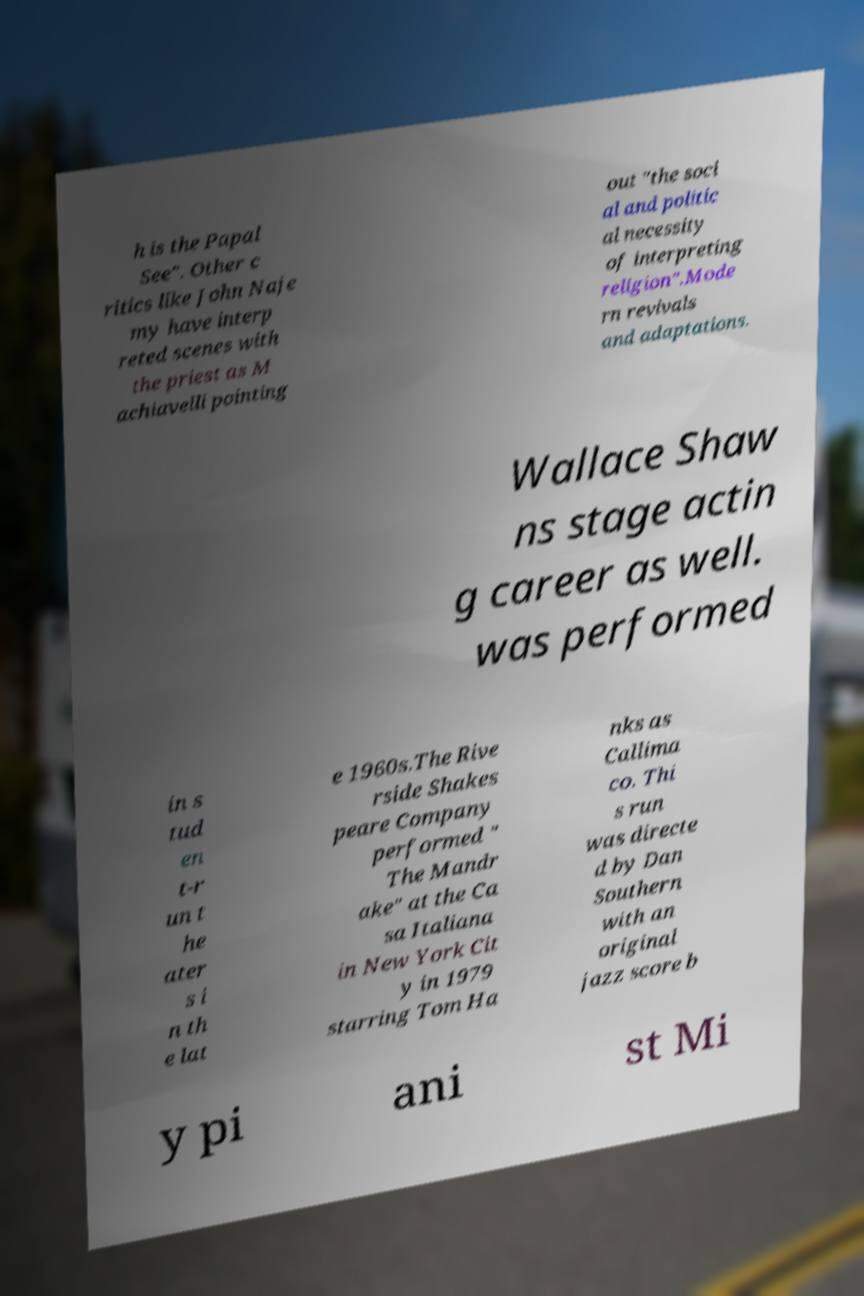Could you assist in decoding the text presented in this image and type it out clearly? h is the Papal See". Other c ritics like John Naje my have interp reted scenes with the priest as M achiavelli pointing out "the soci al and politic al necessity of interpreting religion".Mode rn revivals and adaptations. Wallace Shaw ns stage actin g career as well. was performed in s tud en t-r un t he ater s i n th e lat e 1960s.The Rive rside Shakes peare Company performed " The Mandr ake" at the Ca sa Italiana in New York Cit y in 1979 starring Tom Ha nks as Callima co. Thi s run was directe d by Dan Southern with an original jazz score b y pi ani st Mi 